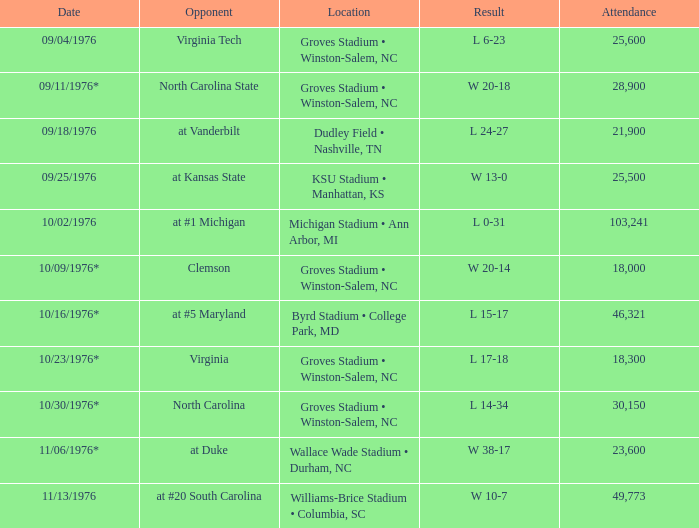Write the full table. {'header': ['Date', 'Opponent', 'Location', 'Result', 'Attendance'], 'rows': [['09/04/1976', 'Virginia Tech', 'Groves Stadium • Winston-Salem, NC', 'L 6-23', '25,600'], ['09/11/1976*', 'North Carolina State', 'Groves Stadium • Winston-Salem, NC', 'W 20-18', '28,900'], ['09/18/1976', 'at Vanderbilt', 'Dudley Field • Nashville, TN', 'L 24-27', '21,900'], ['09/25/1976', 'at Kansas State', 'KSU Stadium • Manhattan, KS', 'W 13-0', '25,500'], ['10/02/1976', 'at #1 Michigan', 'Michigan Stadium • Ann Arbor, MI', 'L 0-31', '103,241'], ['10/09/1976*', 'Clemson', 'Groves Stadium • Winston-Salem, NC', 'W 20-14', '18,000'], ['10/16/1976*', 'at #5 Maryland', 'Byrd Stadium • College Park, MD', 'L 15-17', '46,321'], ['10/23/1976*', 'Virginia', 'Groves Stadium • Winston-Salem, NC', 'L 17-18', '18,300'], ['10/30/1976*', 'North Carolina', 'Groves Stadium • Winston-Salem, NC', 'L 14-34', '30,150'], ['11/06/1976*', 'at Duke', 'Wallace Wade Stadium • Durham, NC', 'W 38-17', '23,600'], ['11/13/1976', 'at #20 South Carolina', 'Williams-Brice Stadium • Columbia, SC', 'W 10-7', '49,773']]} What was the date of the game against North Carolina? 10/30/1976*. 